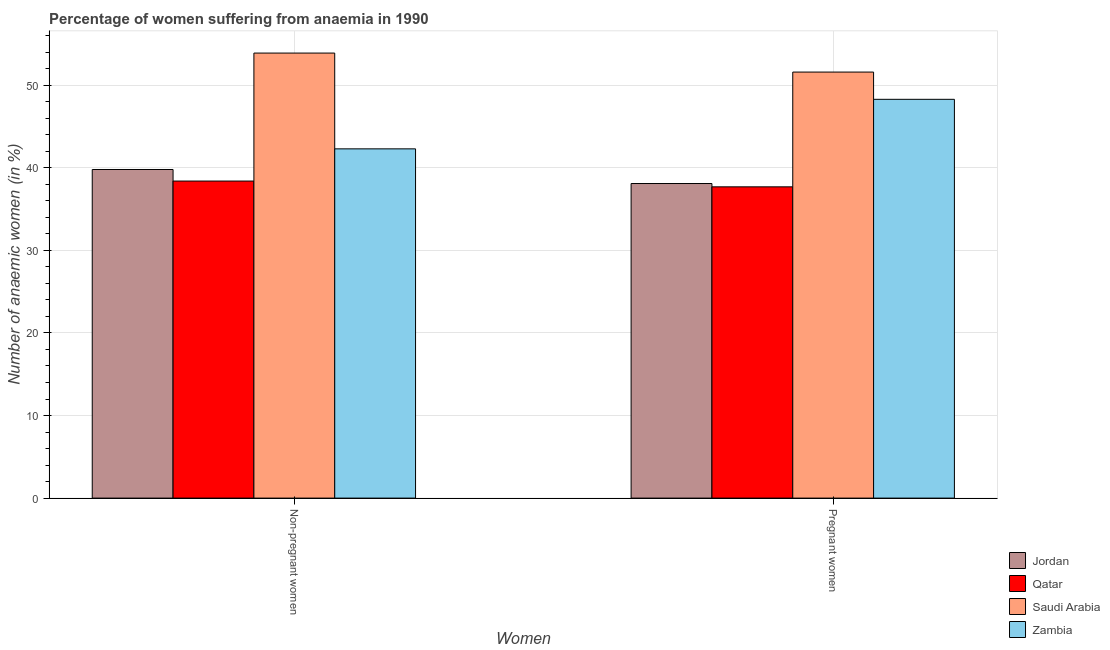How many different coloured bars are there?
Your response must be concise. 4. How many groups of bars are there?
Ensure brevity in your answer.  2. Are the number of bars per tick equal to the number of legend labels?
Offer a very short reply. Yes. Are the number of bars on each tick of the X-axis equal?
Offer a very short reply. Yes. How many bars are there on the 1st tick from the left?
Keep it short and to the point. 4. What is the label of the 1st group of bars from the left?
Provide a short and direct response. Non-pregnant women. What is the percentage of pregnant anaemic women in Zambia?
Ensure brevity in your answer.  48.3. Across all countries, what is the maximum percentage of non-pregnant anaemic women?
Your answer should be compact. 53.9. Across all countries, what is the minimum percentage of pregnant anaemic women?
Ensure brevity in your answer.  37.7. In which country was the percentage of pregnant anaemic women maximum?
Your answer should be very brief. Saudi Arabia. In which country was the percentage of pregnant anaemic women minimum?
Offer a very short reply. Qatar. What is the total percentage of non-pregnant anaemic women in the graph?
Your answer should be very brief. 174.4. What is the difference between the percentage of pregnant anaemic women in Saudi Arabia and that in Jordan?
Give a very brief answer. 13.5. What is the difference between the percentage of pregnant anaemic women in Qatar and the percentage of non-pregnant anaemic women in Jordan?
Offer a terse response. -2.1. What is the average percentage of pregnant anaemic women per country?
Ensure brevity in your answer.  43.92. What is the difference between the percentage of non-pregnant anaemic women and percentage of pregnant anaemic women in Jordan?
Your answer should be compact. 1.7. In how many countries, is the percentage of non-pregnant anaemic women greater than 38 %?
Provide a succinct answer. 4. What is the ratio of the percentage of non-pregnant anaemic women in Zambia to that in Saudi Arabia?
Offer a terse response. 0.78. Is the percentage of pregnant anaemic women in Saudi Arabia less than that in Zambia?
Give a very brief answer. No. What does the 1st bar from the left in Non-pregnant women represents?
Provide a short and direct response. Jordan. What does the 2nd bar from the right in Pregnant women represents?
Your answer should be compact. Saudi Arabia. Are all the bars in the graph horizontal?
Offer a very short reply. No. Are the values on the major ticks of Y-axis written in scientific E-notation?
Give a very brief answer. No. How are the legend labels stacked?
Your answer should be very brief. Vertical. What is the title of the graph?
Offer a terse response. Percentage of women suffering from anaemia in 1990. What is the label or title of the X-axis?
Your response must be concise. Women. What is the label or title of the Y-axis?
Provide a short and direct response. Number of anaemic women (in %). What is the Number of anaemic women (in %) in Jordan in Non-pregnant women?
Offer a very short reply. 39.8. What is the Number of anaemic women (in %) in Qatar in Non-pregnant women?
Your response must be concise. 38.4. What is the Number of anaemic women (in %) in Saudi Arabia in Non-pregnant women?
Provide a short and direct response. 53.9. What is the Number of anaemic women (in %) in Zambia in Non-pregnant women?
Your response must be concise. 42.3. What is the Number of anaemic women (in %) in Jordan in Pregnant women?
Ensure brevity in your answer.  38.1. What is the Number of anaemic women (in %) in Qatar in Pregnant women?
Offer a terse response. 37.7. What is the Number of anaemic women (in %) of Saudi Arabia in Pregnant women?
Offer a terse response. 51.6. What is the Number of anaemic women (in %) of Zambia in Pregnant women?
Your answer should be compact. 48.3. Across all Women, what is the maximum Number of anaemic women (in %) in Jordan?
Provide a short and direct response. 39.8. Across all Women, what is the maximum Number of anaemic women (in %) in Qatar?
Your answer should be very brief. 38.4. Across all Women, what is the maximum Number of anaemic women (in %) of Saudi Arabia?
Offer a very short reply. 53.9. Across all Women, what is the maximum Number of anaemic women (in %) of Zambia?
Provide a short and direct response. 48.3. Across all Women, what is the minimum Number of anaemic women (in %) in Jordan?
Offer a very short reply. 38.1. Across all Women, what is the minimum Number of anaemic women (in %) of Qatar?
Your answer should be compact. 37.7. Across all Women, what is the minimum Number of anaemic women (in %) of Saudi Arabia?
Keep it short and to the point. 51.6. Across all Women, what is the minimum Number of anaemic women (in %) in Zambia?
Offer a terse response. 42.3. What is the total Number of anaemic women (in %) of Jordan in the graph?
Your answer should be very brief. 77.9. What is the total Number of anaemic women (in %) of Qatar in the graph?
Make the answer very short. 76.1. What is the total Number of anaemic women (in %) of Saudi Arabia in the graph?
Your answer should be compact. 105.5. What is the total Number of anaemic women (in %) in Zambia in the graph?
Ensure brevity in your answer.  90.6. What is the difference between the Number of anaemic women (in %) in Jordan in Non-pregnant women and that in Pregnant women?
Make the answer very short. 1.7. What is the difference between the Number of anaemic women (in %) in Qatar in Non-pregnant women and that in Pregnant women?
Your response must be concise. 0.7. What is the difference between the Number of anaemic women (in %) in Saudi Arabia in Non-pregnant women and that in Pregnant women?
Offer a very short reply. 2.3. What is the difference between the Number of anaemic women (in %) in Zambia in Non-pregnant women and that in Pregnant women?
Keep it short and to the point. -6. What is the difference between the Number of anaemic women (in %) in Qatar in Non-pregnant women and the Number of anaemic women (in %) in Saudi Arabia in Pregnant women?
Provide a short and direct response. -13.2. What is the difference between the Number of anaemic women (in %) in Saudi Arabia in Non-pregnant women and the Number of anaemic women (in %) in Zambia in Pregnant women?
Make the answer very short. 5.6. What is the average Number of anaemic women (in %) of Jordan per Women?
Your answer should be compact. 38.95. What is the average Number of anaemic women (in %) of Qatar per Women?
Provide a short and direct response. 38.05. What is the average Number of anaemic women (in %) in Saudi Arabia per Women?
Offer a terse response. 52.75. What is the average Number of anaemic women (in %) of Zambia per Women?
Ensure brevity in your answer.  45.3. What is the difference between the Number of anaemic women (in %) in Jordan and Number of anaemic women (in %) in Saudi Arabia in Non-pregnant women?
Your answer should be very brief. -14.1. What is the difference between the Number of anaemic women (in %) in Qatar and Number of anaemic women (in %) in Saudi Arabia in Non-pregnant women?
Make the answer very short. -15.5. What is the difference between the Number of anaemic women (in %) in Saudi Arabia and Number of anaemic women (in %) in Zambia in Non-pregnant women?
Give a very brief answer. 11.6. What is the difference between the Number of anaemic women (in %) in Jordan and Number of anaemic women (in %) in Qatar in Pregnant women?
Provide a short and direct response. 0.4. What is the difference between the Number of anaemic women (in %) of Jordan and Number of anaemic women (in %) of Saudi Arabia in Pregnant women?
Provide a succinct answer. -13.5. What is the difference between the Number of anaemic women (in %) of Saudi Arabia and Number of anaemic women (in %) of Zambia in Pregnant women?
Offer a terse response. 3.3. What is the ratio of the Number of anaemic women (in %) in Jordan in Non-pregnant women to that in Pregnant women?
Provide a short and direct response. 1.04. What is the ratio of the Number of anaemic women (in %) in Qatar in Non-pregnant women to that in Pregnant women?
Your answer should be compact. 1.02. What is the ratio of the Number of anaemic women (in %) in Saudi Arabia in Non-pregnant women to that in Pregnant women?
Offer a terse response. 1.04. What is the ratio of the Number of anaemic women (in %) of Zambia in Non-pregnant women to that in Pregnant women?
Ensure brevity in your answer.  0.88. What is the difference between the highest and the second highest Number of anaemic women (in %) in Saudi Arabia?
Ensure brevity in your answer.  2.3. What is the difference between the highest and the lowest Number of anaemic women (in %) of Jordan?
Your answer should be very brief. 1.7. What is the difference between the highest and the lowest Number of anaemic women (in %) of Saudi Arabia?
Offer a very short reply. 2.3. What is the difference between the highest and the lowest Number of anaemic women (in %) in Zambia?
Your response must be concise. 6. 